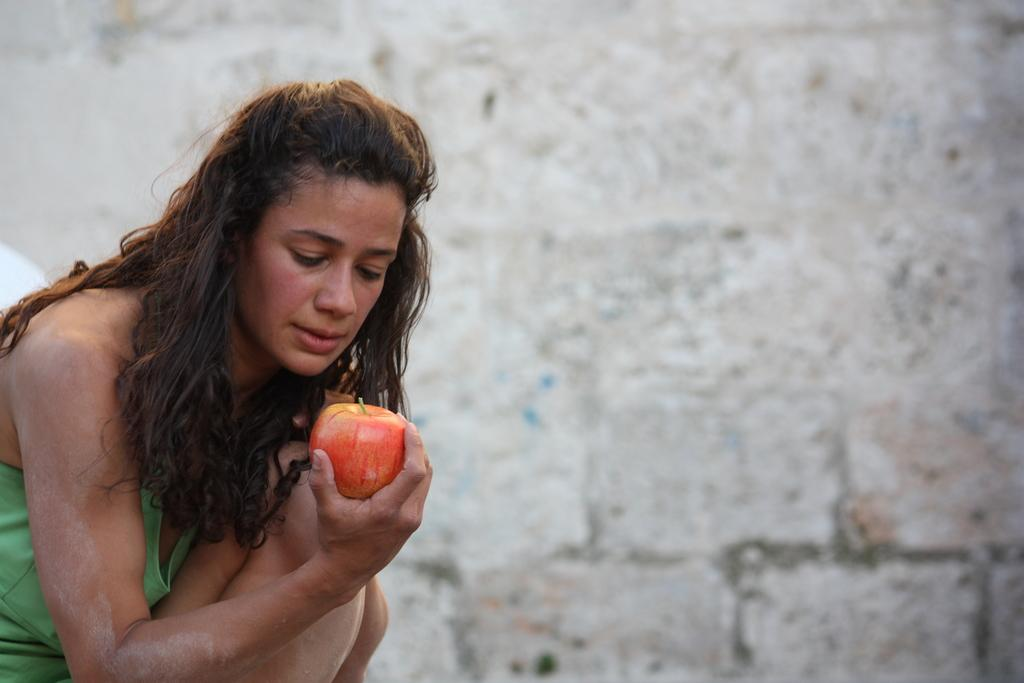Who is present in the image? There is a woman in the image. What is the woman wearing? The woman is wearing a green dress. What is the woman holding in the image? The woman is holding an apple. What can be seen in the background of the image? There is a white-colored wall in the background of the image. What type of drum is the squirrel playing in the image? There is no squirrel or drum present in the image. What color are the woman's trousers in the image? The woman is not wearing trousers in the image; she is wearing a green dress. 